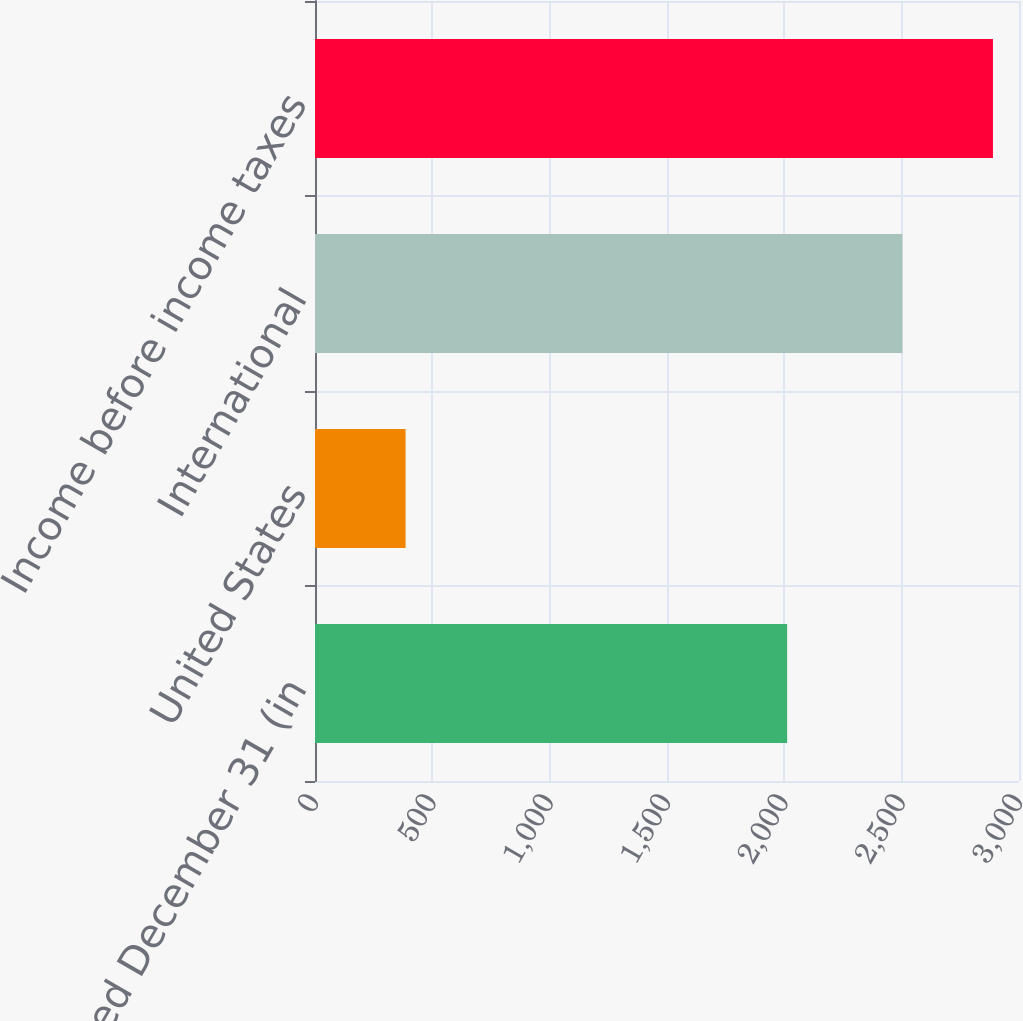<chart> <loc_0><loc_0><loc_500><loc_500><bar_chart><fcel>years ended December 31 (in<fcel>United States<fcel>International<fcel>Income before income taxes<nl><fcel>2012<fcel>386<fcel>2503<fcel>2889<nl></chart> 